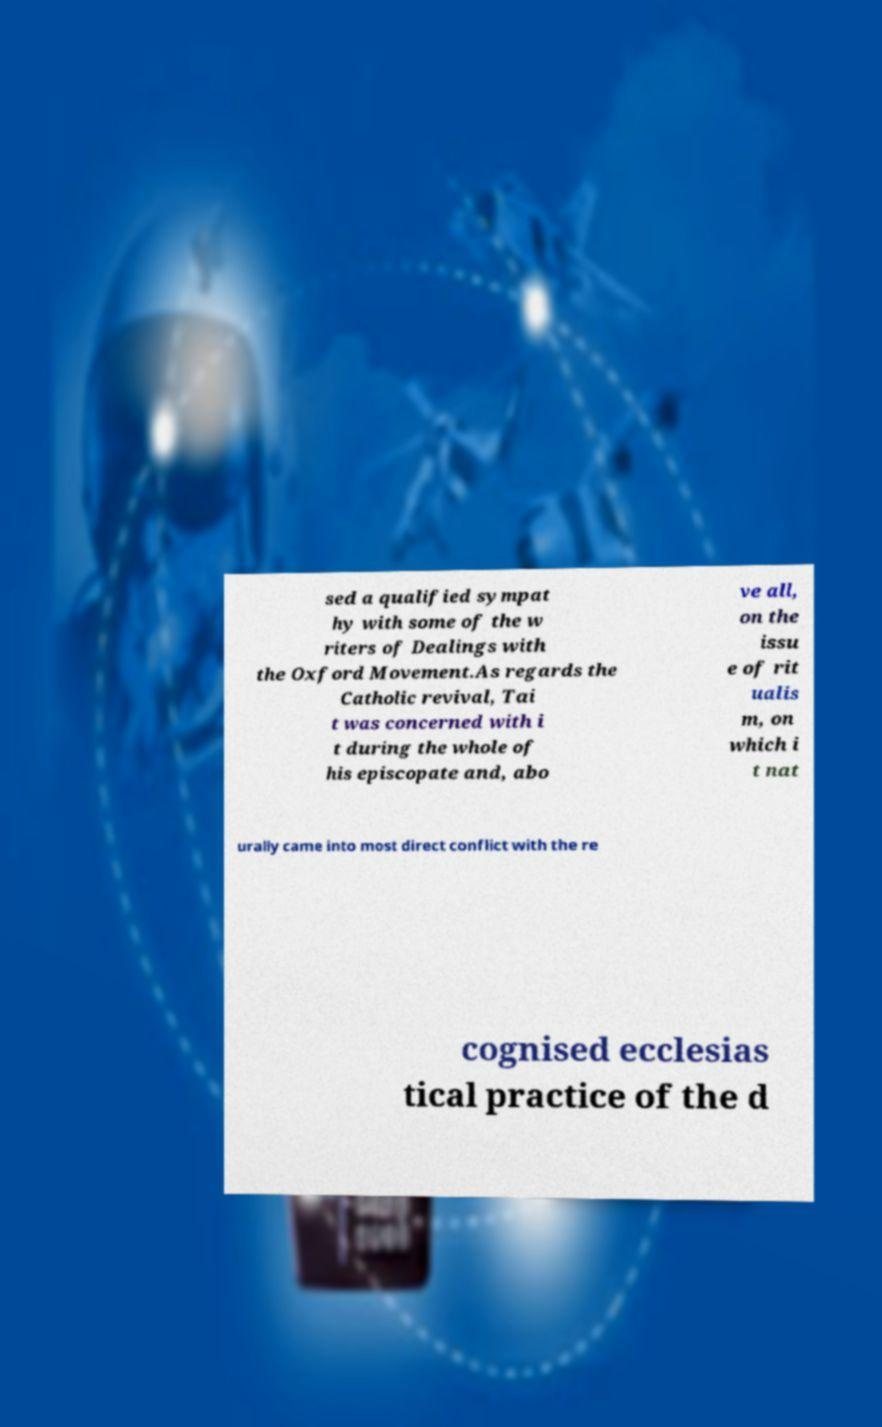What messages or text are displayed in this image? I need them in a readable, typed format. sed a qualified sympat hy with some of the w riters of Dealings with the Oxford Movement.As regards the Catholic revival, Tai t was concerned with i t during the whole of his episcopate and, abo ve all, on the issu e of rit ualis m, on which i t nat urally came into most direct conflict with the re cognised ecclesias tical practice of the d 